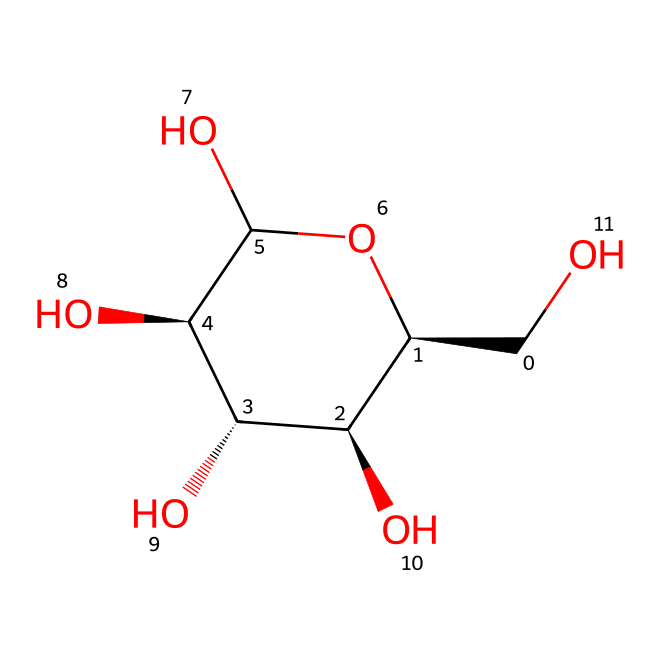What is the molecular formula of glucose? The molecular formula can be determined by counting the carbon (C), hydrogen (H), and oxygen (O) atoms visible in the structure. In the SMILES representation, there are 6 carbon atoms, 12 hydrogen atoms, and 6 oxygen atoms, leading to a total molecular formula of C6H12O6.
Answer: C6H12O6 How many hydroxyl (–OH) groups are present in glucose? By examining the structure, we can identify the hydroxyl (–OH) groups attached to the carbon atoms. There are 5 hydroxyl groups in the glucose structure, confirming its classification as a polyol.
Answer: 5 What type of carbohydrate is glucose classified as? Glucose is a simple sugar or monosaccharide, which is determined by its single-ring structure and the presence of multiple –OH groups that characterize monosaccharides compared to oligosaccharides or polysaccharides.
Answer: monosaccharide How many chiral centers are present in glucose? Chiral centers can be identified by observing the carbon atoms that have four different substituents attached. In the structure of glucose, there are 4 chiral centers located at carbon atoms 2, 3, 4, and 5.
Answer: 4 What is the configuration of the chiral center at carbon 2 in glucose? The configuration can be assessed by looking at the spatial arrangement of the substituents around carbon 2. If the –OH group is on the right in the Fischer projection, then it has an R configuration; since in glucose, it is on the left, it is determined to be S.
Answer: S What is the significance of the aldehyde functional group in glucose? The aldehyde group, located at carbon 1 in glucose, defines the sugar as an aldose carbohydrate. This impacts its reactivity and structure compared to ketoses, which contain a ketone functional group.
Answer: aldose 